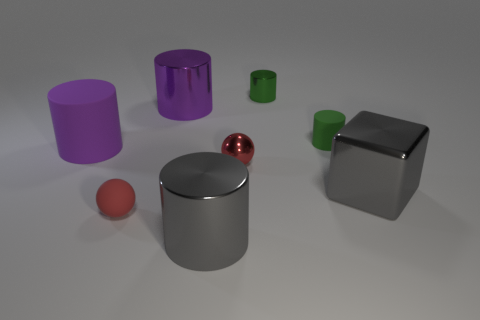Subtract 1 cylinders. How many cylinders are left? 4 Subtract all brown cylinders. Subtract all gray blocks. How many cylinders are left? 5 Add 2 metal balls. How many objects exist? 10 Subtract all cylinders. How many objects are left? 3 Add 8 green rubber cylinders. How many green rubber cylinders exist? 9 Subtract 0 purple spheres. How many objects are left? 8 Subtract all green shiny cylinders. Subtract all small balls. How many objects are left? 5 Add 7 small red things. How many small red things are left? 9 